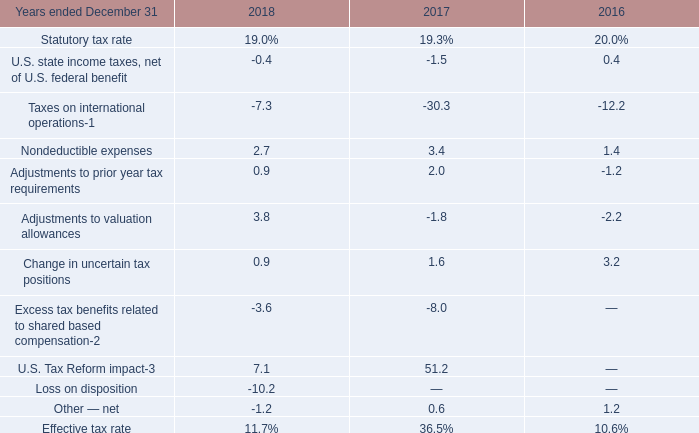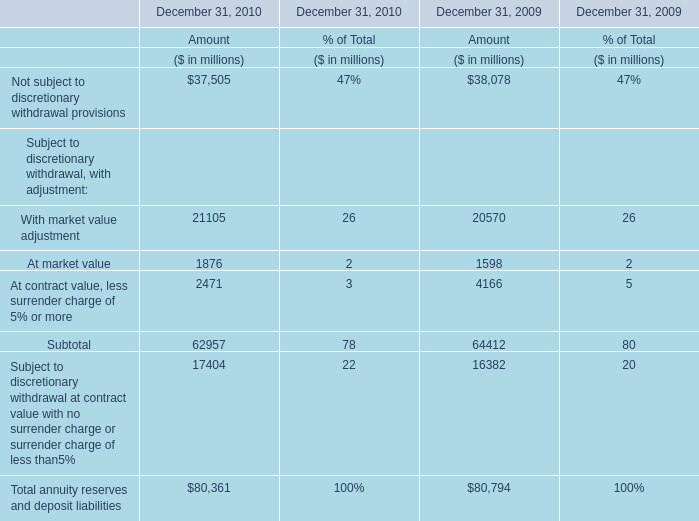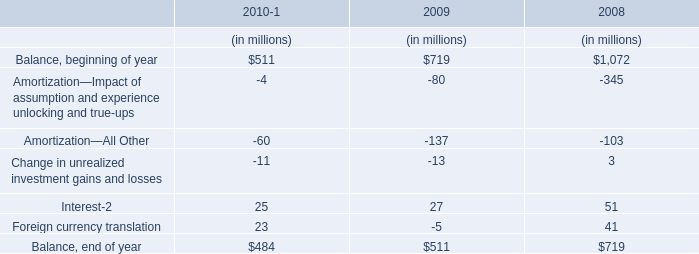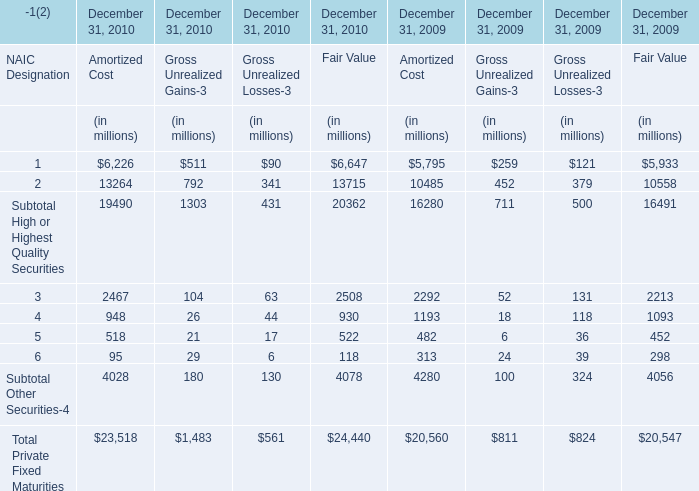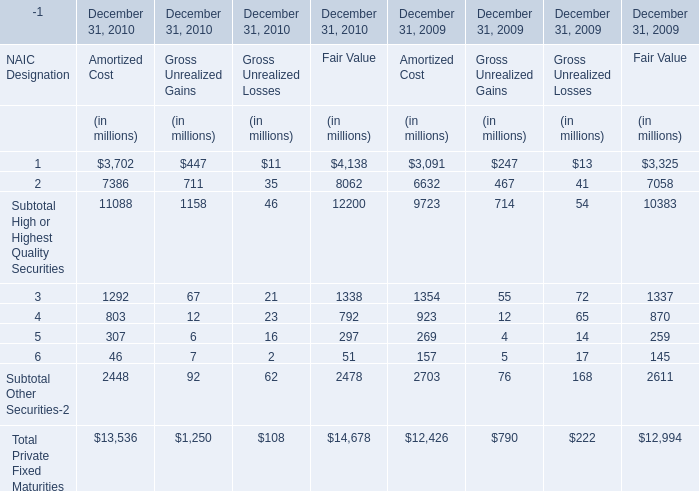What was the total amount of the Subtotal Other Securities in the years where Subtotal High or Highest Quality Securities for Amortized Cost is greater than 2000? (in million) 
Computations: (4028 + 4280)
Answer: 8308.0. 